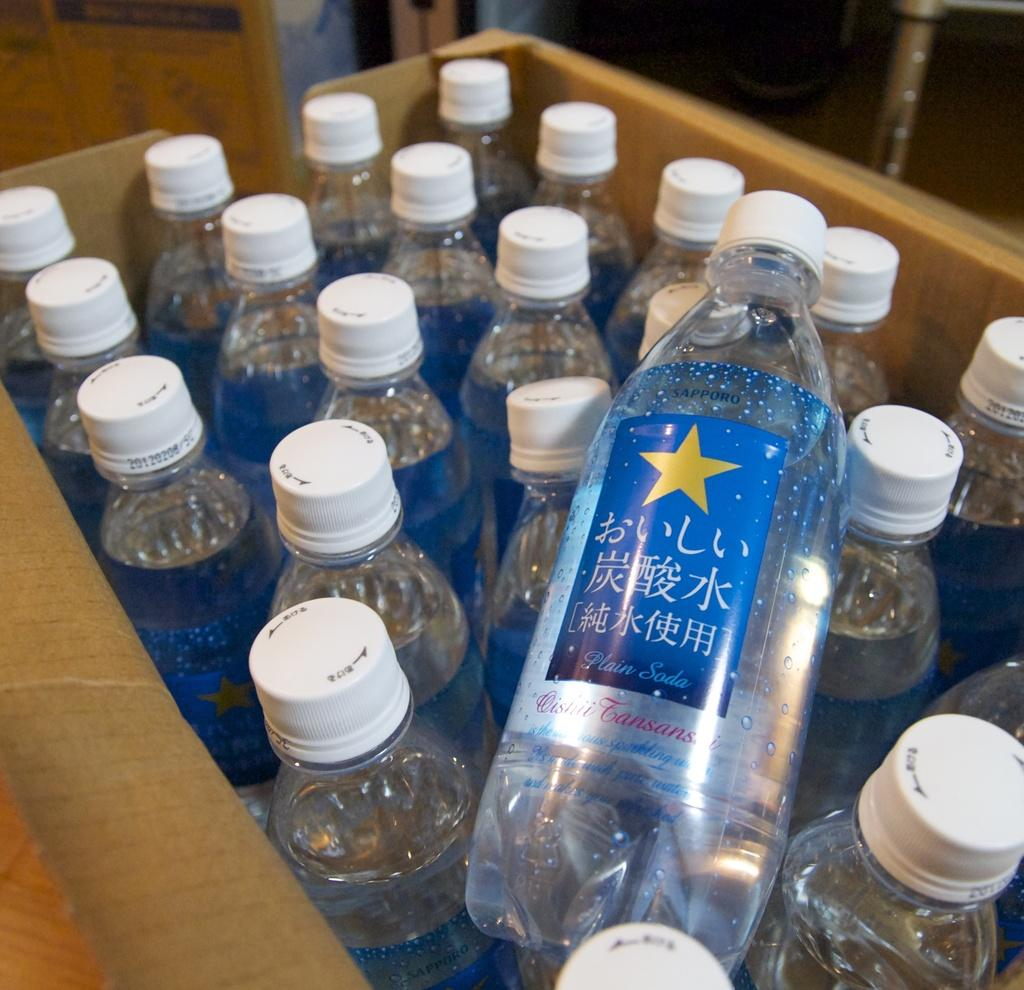What objects are in the image? There is a group of water bottles in a box in the image. How are the water bottles arranged in the image? The water bottles are in a box in the image. What might be the purpose of the box in the image? The box might be used for organizing or transporting the water bottles. What type of harmony can be heard from the snails in the image? There are no snails present in the image, so it is not possible to determine if they are producing any harmony. What is the bucket used for in the image? There is no bucket present in the image. 